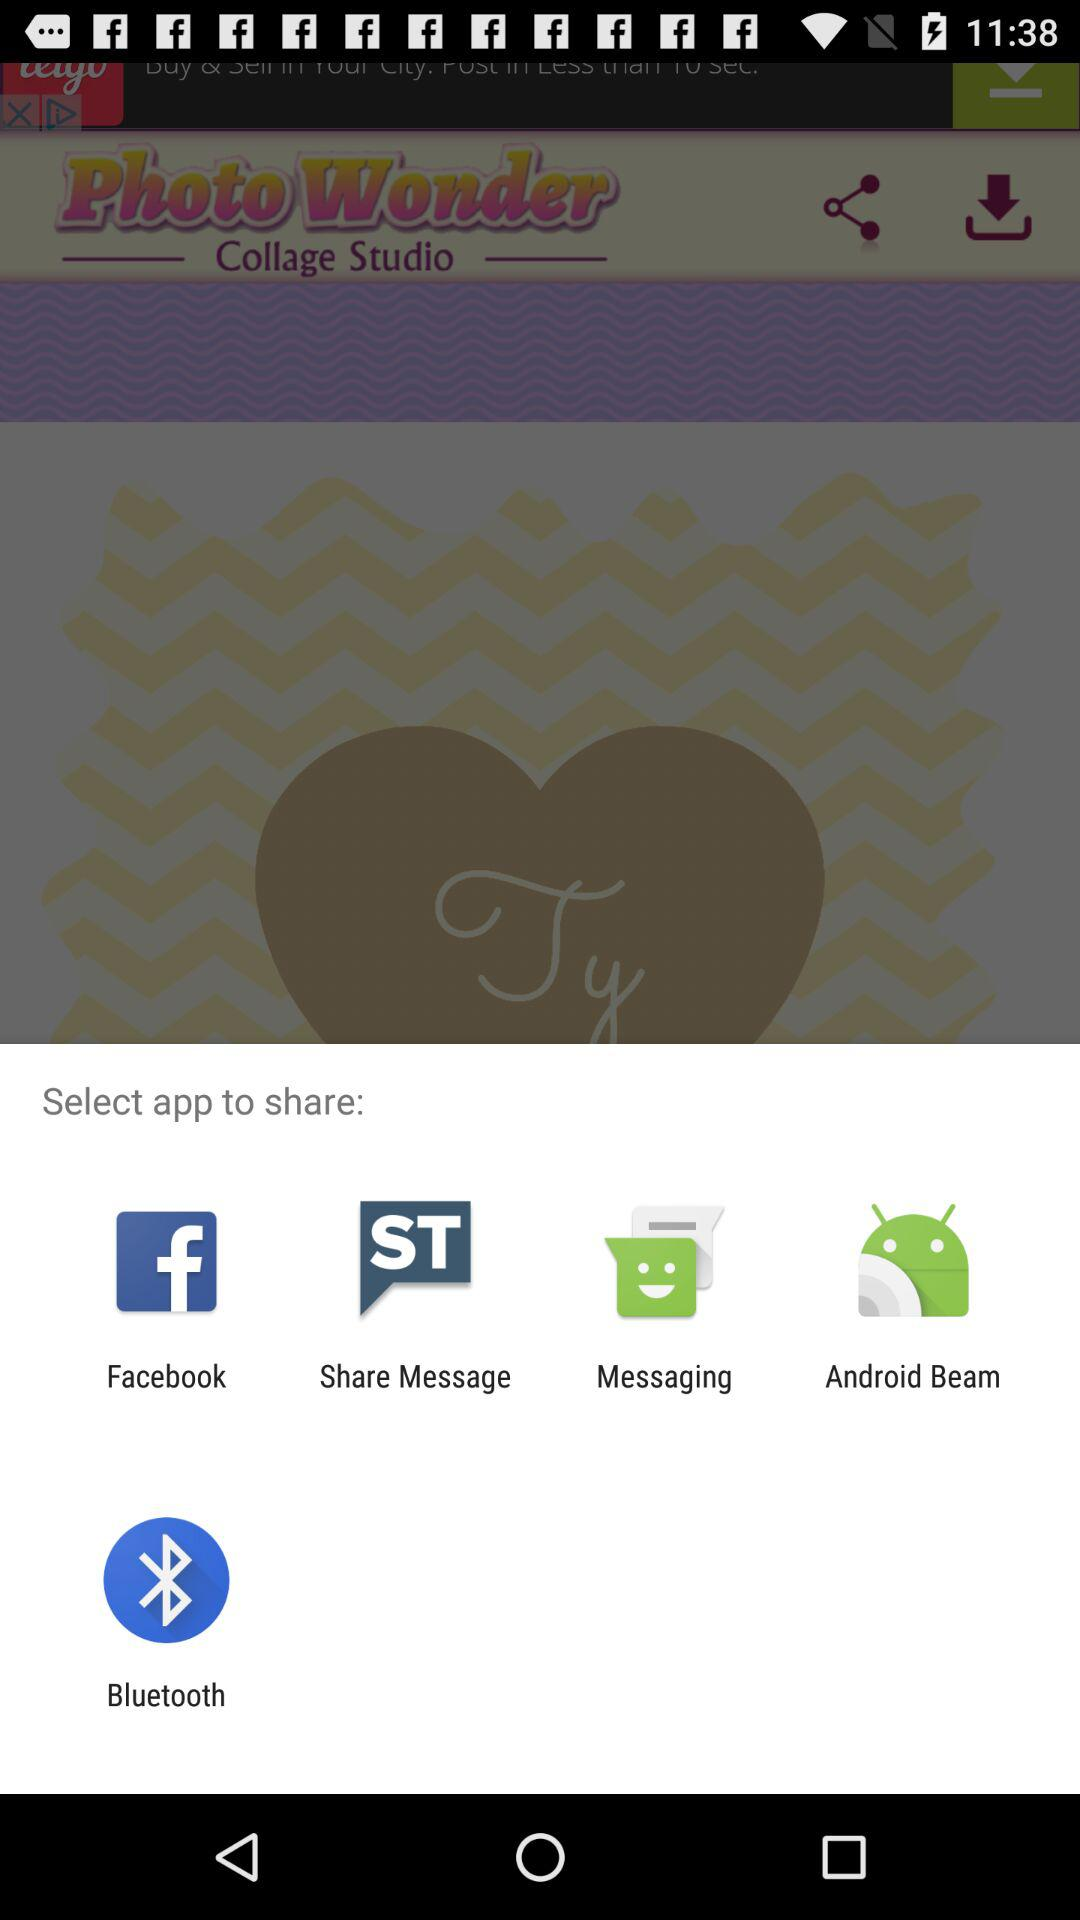Through which applications can it be shared? It can be shared through "Facebook", "Share Message", "Messaging", "Android Beam" and "Bluetooth". 